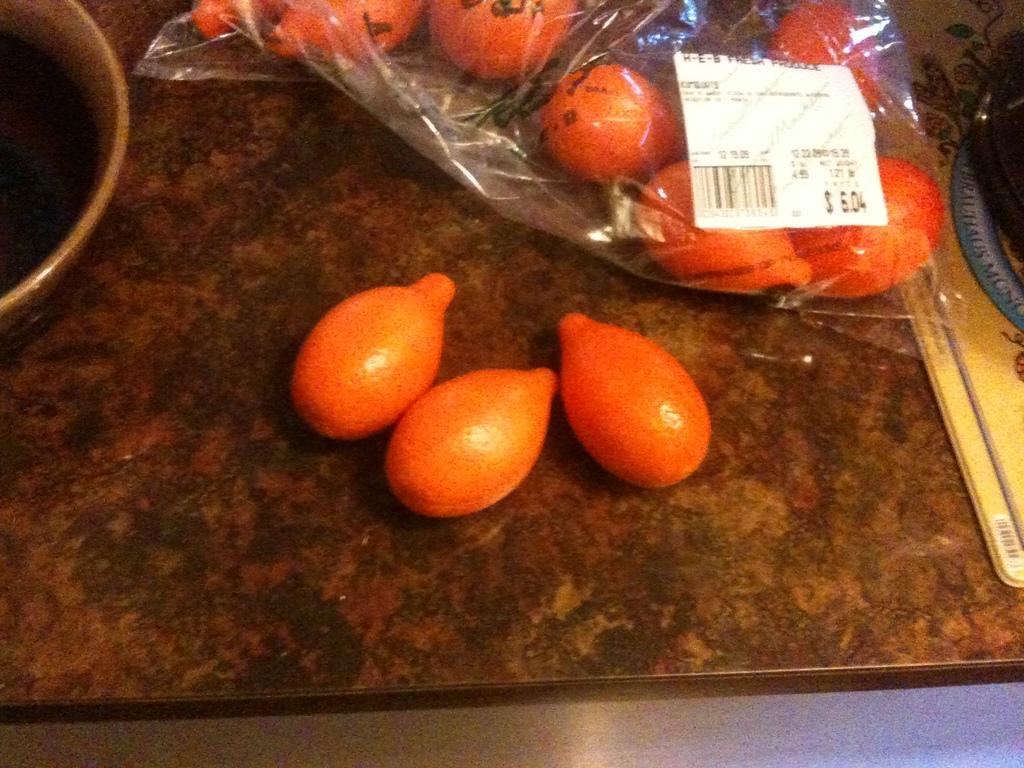Describe this image in one or two sentences. In this image, we can see some fruits on the stone and we can see some containers. 